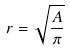<formula> <loc_0><loc_0><loc_500><loc_500>r = \sqrt { \frac { A } { \pi } }</formula> 